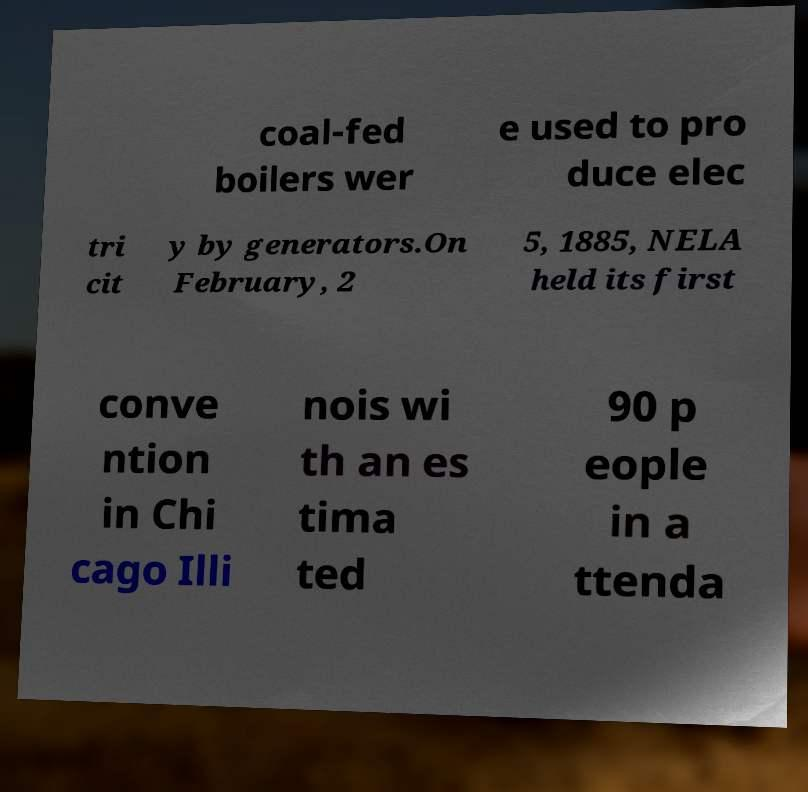Can you read and provide the text displayed in the image?This photo seems to have some interesting text. Can you extract and type it out for me? coal-fed boilers wer e used to pro duce elec tri cit y by generators.On February, 2 5, 1885, NELA held its first conve ntion in Chi cago Illi nois wi th an es tima ted 90 p eople in a ttenda 